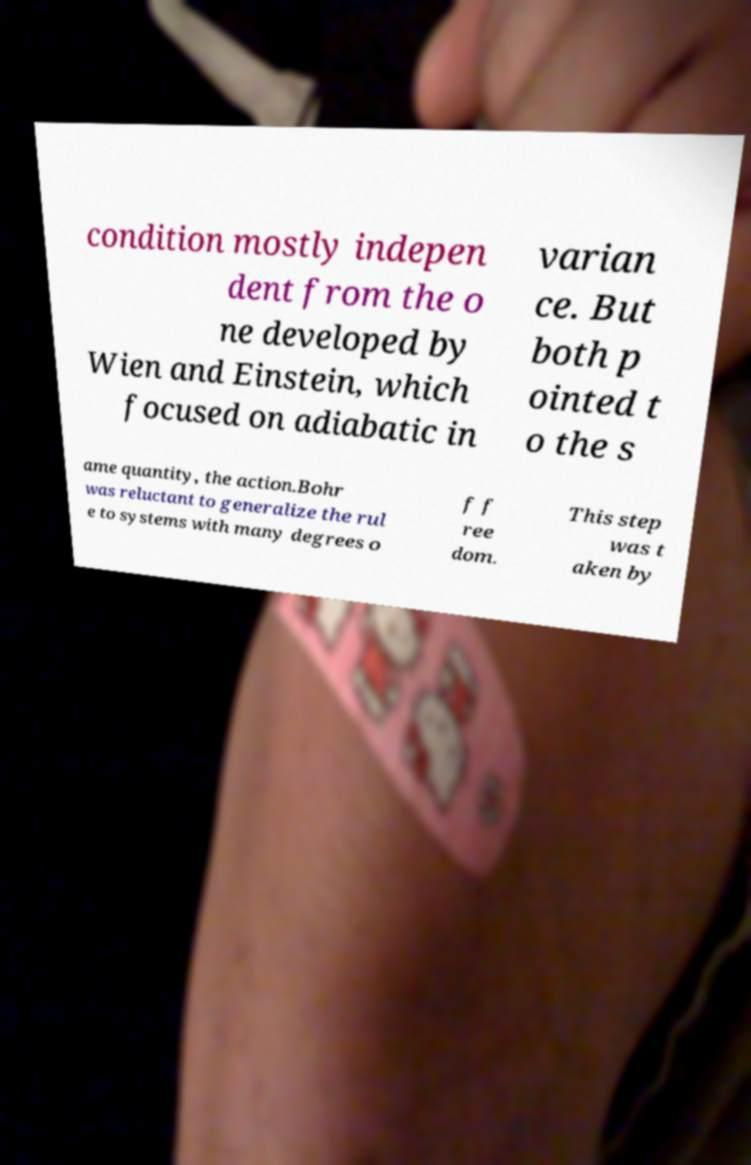Can you accurately transcribe the text from the provided image for me? condition mostly indepen dent from the o ne developed by Wien and Einstein, which focused on adiabatic in varian ce. But both p ointed t o the s ame quantity, the action.Bohr was reluctant to generalize the rul e to systems with many degrees o f f ree dom. This step was t aken by 